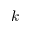Convert formula to latex. <formula><loc_0><loc_0><loc_500><loc_500>k</formula> 